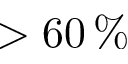<formula> <loc_0><loc_0><loc_500><loc_500>> 6 0 \, \%</formula> 